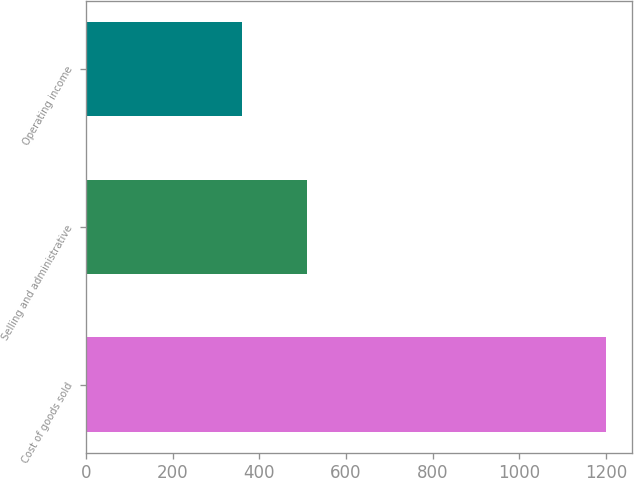Convert chart. <chart><loc_0><loc_0><loc_500><loc_500><bar_chart><fcel>Cost of goods sold<fcel>Selling and administrative<fcel>Operating income<nl><fcel>1199<fcel>510.5<fcel>358.6<nl></chart> 